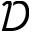<formula> <loc_0><loc_0><loc_500><loc_500>\ m a t h s c r { D }</formula> 